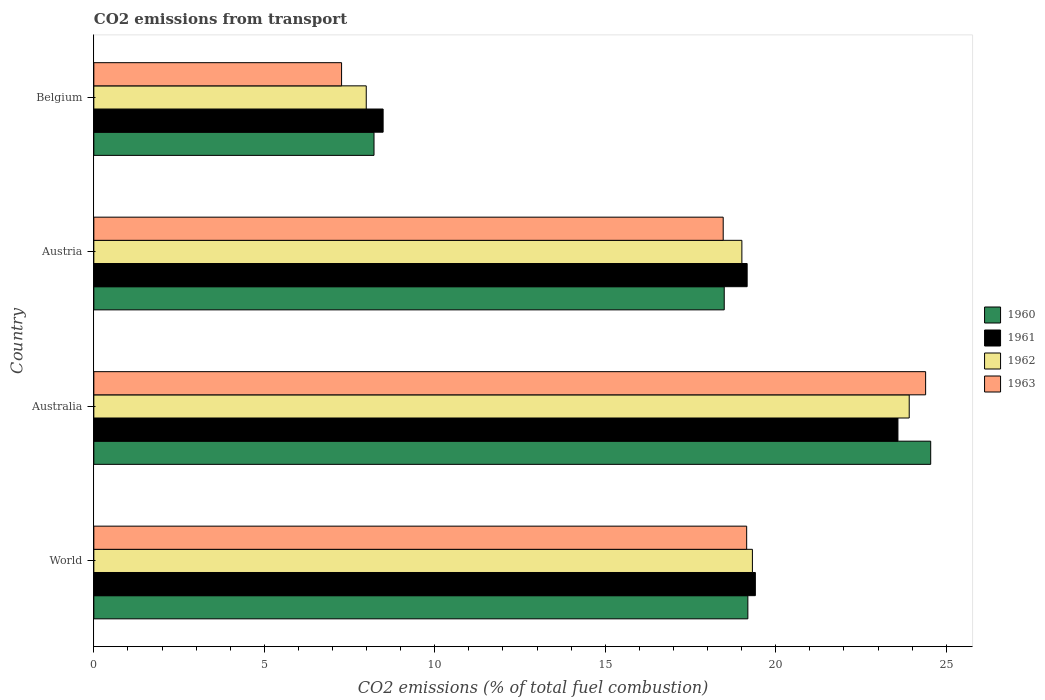How many different coloured bars are there?
Offer a terse response. 4. How many groups of bars are there?
Keep it short and to the point. 4. Are the number of bars on each tick of the Y-axis equal?
Your answer should be compact. Yes. How many bars are there on the 4th tick from the top?
Your response must be concise. 4. How many bars are there on the 2nd tick from the bottom?
Ensure brevity in your answer.  4. What is the label of the 1st group of bars from the top?
Your answer should be compact. Belgium. In how many cases, is the number of bars for a given country not equal to the number of legend labels?
Make the answer very short. 0. What is the total CO2 emitted in 1963 in World?
Keep it short and to the point. 19.15. Across all countries, what is the maximum total CO2 emitted in 1961?
Provide a succinct answer. 23.59. Across all countries, what is the minimum total CO2 emitted in 1961?
Your answer should be compact. 8.49. In which country was the total CO2 emitted in 1960 minimum?
Your answer should be compact. Belgium. What is the total total CO2 emitted in 1961 in the graph?
Your answer should be compact. 70.64. What is the difference between the total CO2 emitted in 1962 in Belgium and that in World?
Keep it short and to the point. -11.33. What is the difference between the total CO2 emitted in 1960 in Australia and the total CO2 emitted in 1963 in World?
Give a very brief answer. 5.4. What is the average total CO2 emitted in 1961 per country?
Give a very brief answer. 17.66. What is the difference between the total CO2 emitted in 1962 and total CO2 emitted in 1963 in Austria?
Provide a succinct answer. 0.55. In how many countries, is the total CO2 emitted in 1960 greater than 24 ?
Give a very brief answer. 1. What is the ratio of the total CO2 emitted in 1960 in Austria to that in Belgium?
Give a very brief answer. 2.25. What is the difference between the highest and the second highest total CO2 emitted in 1962?
Ensure brevity in your answer.  4.6. What is the difference between the highest and the lowest total CO2 emitted in 1962?
Ensure brevity in your answer.  15.93. In how many countries, is the total CO2 emitted in 1963 greater than the average total CO2 emitted in 1963 taken over all countries?
Provide a short and direct response. 3. Is the sum of the total CO2 emitted in 1961 in Belgium and World greater than the maximum total CO2 emitted in 1962 across all countries?
Your answer should be very brief. Yes. Is it the case that in every country, the sum of the total CO2 emitted in 1962 and total CO2 emitted in 1963 is greater than the total CO2 emitted in 1961?
Offer a terse response. Yes. How many countries are there in the graph?
Provide a short and direct response. 4. Does the graph contain any zero values?
Give a very brief answer. No. How are the legend labels stacked?
Offer a very short reply. Vertical. What is the title of the graph?
Ensure brevity in your answer.  CO2 emissions from transport. Does "2004" appear as one of the legend labels in the graph?
Your response must be concise. No. What is the label or title of the X-axis?
Ensure brevity in your answer.  CO2 emissions (% of total fuel combustion). What is the CO2 emissions (% of total fuel combustion) of 1960 in World?
Keep it short and to the point. 19.18. What is the CO2 emissions (% of total fuel combustion) in 1961 in World?
Make the answer very short. 19.4. What is the CO2 emissions (% of total fuel combustion) in 1962 in World?
Keep it short and to the point. 19.32. What is the CO2 emissions (% of total fuel combustion) in 1963 in World?
Provide a short and direct response. 19.15. What is the CO2 emissions (% of total fuel combustion) of 1960 in Australia?
Your answer should be compact. 24.55. What is the CO2 emissions (% of total fuel combustion) in 1961 in Australia?
Make the answer very short. 23.59. What is the CO2 emissions (% of total fuel combustion) of 1962 in Australia?
Your answer should be compact. 23.92. What is the CO2 emissions (% of total fuel combustion) in 1963 in Australia?
Your response must be concise. 24.4. What is the CO2 emissions (% of total fuel combustion) of 1960 in Austria?
Your answer should be very brief. 18.49. What is the CO2 emissions (% of total fuel combustion) in 1961 in Austria?
Offer a very short reply. 19.16. What is the CO2 emissions (% of total fuel combustion) in 1962 in Austria?
Provide a succinct answer. 19.01. What is the CO2 emissions (% of total fuel combustion) of 1963 in Austria?
Your answer should be compact. 18.46. What is the CO2 emissions (% of total fuel combustion) of 1960 in Belgium?
Offer a very short reply. 8.22. What is the CO2 emissions (% of total fuel combustion) of 1961 in Belgium?
Offer a very short reply. 8.49. What is the CO2 emissions (% of total fuel combustion) of 1962 in Belgium?
Your answer should be compact. 7.99. What is the CO2 emissions (% of total fuel combustion) of 1963 in Belgium?
Offer a terse response. 7.27. Across all countries, what is the maximum CO2 emissions (% of total fuel combustion) in 1960?
Offer a very short reply. 24.55. Across all countries, what is the maximum CO2 emissions (% of total fuel combustion) in 1961?
Make the answer very short. 23.59. Across all countries, what is the maximum CO2 emissions (% of total fuel combustion) of 1962?
Ensure brevity in your answer.  23.92. Across all countries, what is the maximum CO2 emissions (% of total fuel combustion) of 1963?
Offer a very short reply. 24.4. Across all countries, what is the minimum CO2 emissions (% of total fuel combustion) of 1960?
Provide a succinct answer. 8.22. Across all countries, what is the minimum CO2 emissions (% of total fuel combustion) of 1961?
Provide a short and direct response. 8.49. Across all countries, what is the minimum CO2 emissions (% of total fuel combustion) of 1962?
Provide a succinct answer. 7.99. Across all countries, what is the minimum CO2 emissions (% of total fuel combustion) in 1963?
Your answer should be compact. 7.27. What is the total CO2 emissions (% of total fuel combustion) of 1960 in the graph?
Give a very brief answer. 70.44. What is the total CO2 emissions (% of total fuel combustion) in 1961 in the graph?
Ensure brevity in your answer.  70.64. What is the total CO2 emissions (% of total fuel combustion) of 1962 in the graph?
Provide a succinct answer. 70.23. What is the total CO2 emissions (% of total fuel combustion) in 1963 in the graph?
Provide a short and direct response. 69.27. What is the difference between the CO2 emissions (% of total fuel combustion) of 1960 in World and that in Australia?
Your answer should be very brief. -5.36. What is the difference between the CO2 emissions (% of total fuel combustion) in 1961 in World and that in Australia?
Ensure brevity in your answer.  -4.18. What is the difference between the CO2 emissions (% of total fuel combustion) of 1962 in World and that in Australia?
Offer a terse response. -4.6. What is the difference between the CO2 emissions (% of total fuel combustion) of 1963 in World and that in Australia?
Provide a succinct answer. -5.25. What is the difference between the CO2 emissions (% of total fuel combustion) in 1960 in World and that in Austria?
Make the answer very short. 0.69. What is the difference between the CO2 emissions (% of total fuel combustion) of 1961 in World and that in Austria?
Provide a short and direct response. 0.24. What is the difference between the CO2 emissions (% of total fuel combustion) in 1962 in World and that in Austria?
Keep it short and to the point. 0.31. What is the difference between the CO2 emissions (% of total fuel combustion) in 1963 in World and that in Austria?
Keep it short and to the point. 0.69. What is the difference between the CO2 emissions (% of total fuel combustion) in 1960 in World and that in Belgium?
Your response must be concise. 10.96. What is the difference between the CO2 emissions (% of total fuel combustion) of 1961 in World and that in Belgium?
Give a very brief answer. 10.92. What is the difference between the CO2 emissions (% of total fuel combustion) of 1962 in World and that in Belgium?
Ensure brevity in your answer.  11.33. What is the difference between the CO2 emissions (% of total fuel combustion) of 1963 in World and that in Belgium?
Keep it short and to the point. 11.88. What is the difference between the CO2 emissions (% of total fuel combustion) of 1960 in Australia and that in Austria?
Make the answer very short. 6.06. What is the difference between the CO2 emissions (% of total fuel combustion) of 1961 in Australia and that in Austria?
Provide a succinct answer. 4.42. What is the difference between the CO2 emissions (% of total fuel combustion) of 1962 in Australia and that in Austria?
Offer a very short reply. 4.91. What is the difference between the CO2 emissions (% of total fuel combustion) of 1963 in Australia and that in Austria?
Your answer should be very brief. 5.94. What is the difference between the CO2 emissions (% of total fuel combustion) of 1960 in Australia and that in Belgium?
Make the answer very short. 16.33. What is the difference between the CO2 emissions (% of total fuel combustion) in 1961 in Australia and that in Belgium?
Offer a terse response. 15.1. What is the difference between the CO2 emissions (% of total fuel combustion) in 1962 in Australia and that in Belgium?
Give a very brief answer. 15.93. What is the difference between the CO2 emissions (% of total fuel combustion) of 1963 in Australia and that in Belgium?
Provide a short and direct response. 17.13. What is the difference between the CO2 emissions (% of total fuel combustion) of 1960 in Austria and that in Belgium?
Offer a very short reply. 10.27. What is the difference between the CO2 emissions (% of total fuel combustion) of 1961 in Austria and that in Belgium?
Your response must be concise. 10.68. What is the difference between the CO2 emissions (% of total fuel combustion) in 1962 in Austria and that in Belgium?
Your answer should be very brief. 11.02. What is the difference between the CO2 emissions (% of total fuel combustion) of 1963 in Austria and that in Belgium?
Provide a succinct answer. 11.19. What is the difference between the CO2 emissions (% of total fuel combustion) in 1960 in World and the CO2 emissions (% of total fuel combustion) in 1961 in Australia?
Your response must be concise. -4.4. What is the difference between the CO2 emissions (% of total fuel combustion) in 1960 in World and the CO2 emissions (% of total fuel combustion) in 1962 in Australia?
Keep it short and to the point. -4.73. What is the difference between the CO2 emissions (% of total fuel combustion) of 1960 in World and the CO2 emissions (% of total fuel combustion) of 1963 in Australia?
Give a very brief answer. -5.21. What is the difference between the CO2 emissions (% of total fuel combustion) of 1961 in World and the CO2 emissions (% of total fuel combustion) of 1962 in Australia?
Provide a short and direct response. -4.51. What is the difference between the CO2 emissions (% of total fuel combustion) of 1961 in World and the CO2 emissions (% of total fuel combustion) of 1963 in Australia?
Offer a very short reply. -4.99. What is the difference between the CO2 emissions (% of total fuel combustion) of 1962 in World and the CO2 emissions (% of total fuel combustion) of 1963 in Australia?
Make the answer very short. -5.08. What is the difference between the CO2 emissions (% of total fuel combustion) of 1960 in World and the CO2 emissions (% of total fuel combustion) of 1961 in Austria?
Your response must be concise. 0.02. What is the difference between the CO2 emissions (% of total fuel combustion) in 1960 in World and the CO2 emissions (% of total fuel combustion) in 1962 in Austria?
Make the answer very short. 0.18. What is the difference between the CO2 emissions (% of total fuel combustion) in 1960 in World and the CO2 emissions (% of total fuel combustion) in 1963 in Austria?
Give a very brief answer. 0.72. What is the difference between the CO2 emissions (% of total fuel combustion) of 1961 in World and the CO2 emissions (% of total fuel combustion) of 1962 in Austria?
Keep it short and to the point. 0.4. What is the difference between the CO2 emissions (% of total fuel combustion) in 1961 in World and the CO2 emissions (% of total fuel combustion) in 1963 in Austria?
Your answer should be very brief. 0.94. What is the difference between the CO2 emissions (% of total fuel combustion) in 1962 in World and the CO2 emissions (% of total fuel combustion) in 1963 in Austria?
Give a very brief answer. 0.86. What is the difference between the CO2 emissions (% of total fuel combustion) of 1960 in World and the CO2 emissions (% of total fuel combustion) of 1961 in Belgium?
Your response must be concise. 10.7. What is the difference between the CO2 emissions (% of total fuel combustion) of 1960 in World and the CO2 emissions (% of total fuel combustion) of 1962 in Belgium?
Your response must be concise. 11.19. What is the difference between the CO2 emissions (% of total fuel combustion) in 1960 in World and the CO2 emissions (% of total fuel combustion) in 1963 in Belgium?
Your answer should be very brief. 11.92. What is the difference between the CO2 emissions (% of total fuel combustion) of 1961 in World and the CO2 emissions (% of total fuel combustion) of 1962 in Belgium?
Keep it short and to the point. 11.41. What is the difference between the CO2 emissions (% of total fuel combustion) of 1961 in World and the CO2 emissions (% of total fuel combustion) of 1963 in Belgium?
Make the answer very short. 12.14. What is the difference between the CO2 emissions (% of total fuel combustion) of 1962 in World and the CO2 emissions (% of total fuel combustion) of 1963 in Belgium?
Your answer should be very brief. 12.05. What is the difference between the CO2 emissions (% of total fuel combustion) of 1960 in Australia and the CO2 emissions (% of total fuel combustion) of 1961 in Austria?
Your answer should be compact. 5.38. What is the difference between the CO2 emissions (% of total fuel combustion) of 1960 in Australia and the CO2 emissions (% of total fuel combustion) of 1962 in Austria?
Your answer should be compact. 5.54. What is the difference between the CO2 emissions (% of total fuel combustion) of 1960 in Australia and the CO2 emissions (% of total fuel combustion) of 1963 in Austria?
Offer a terse response. 6.09. What is the difference between the CO2 emissions (% of total fuel combustion) in 1961 in Australia and the CO2 emissions (% of total fuel combustion) in 1962 in Austria?
Provide a succinct answer. 4.58. What is the difference between the CO2 emissions (% of total fuel combustion) of 1961 in Australia and the CO2 emissions (% of total fuel combustion) of 1963 in Austria?
Keep it short and to the point. 5.13. What is the difference between the CO2 emissions (% of total fuel combustion) of 1962 in Australia and the CO2 emissions (% of total fuel combustion) of 1963 in Austria?
Ensure brevity in your answer.  5.46. What is the difference between the CO2 emissions (% of total fuel combustion) of 1960 in Australia and the CO2 emissions (% of total fuel combustion) of 1961 in Belgium?
Provide a short and direct response. 16.06. What is the difference between the CO2 emissions (% of total fuel combustion) in 1960 in Australia and the CO2 emissions (% of total fuel combustion) in 1962 in Belgium?
Offer a very short reply. 16.56. What is the difference between the CO2 emissions (% of total fuel combustion) in 1960 in Australia and the CO2 emissions (% of total fuel combustion) in 1963 in Belgium?
Provide a succinct answer. 17.28. What is the difference between the CO2 emissions (% of total fuel combustion) of 1961 in Australia and the CO2 emissions (% of total fuel combustion) of 1962 in Belgium?
Provide a short and direct response. 15.59. What is the difference between the CO2 emissions (% of total fuel combustion) in 1961 in Australia and the CO2 emissions (% of total fuel combustion) in 1963 in Belgium?
Ensure brevity in your answer.  16.32. What is the difference between the CO2 emissions (% of total fuel combustion) in 1962 in Australia and the CO2 emissions (% of total fuel combustion) in 1963 in Belgium?
Offer a very short reply. 16.65. What is the difference between the CO2 emissions (% of total fuel combustion) of 1960 in Austria and the CO2 emissions (% of total fuel combustion) of 1961 in Belgium?
Provide a succinct answer. 10. What is the difference between the CO2 emissions (% of total fuel combustion) in 1960 in Austria and the CO2 emissions (% of total fuel combustion) in 1962 in Belgium?
Your response must be concise. 10.5. What is the difference between the CO2 emissions (% of total fuel combustion) in 1960 in Austria and the CO2 emissions (% of total fuel combustion) in 1963 in Belgium?
Ensure brevity in your answer.  11.22. What is the difference between the CO2 emissions (% of total fuel combustion) in 1961 in Austria and the CO2 emissions (% of total fuel combustion) in 1962 in Belgium?
Your answer should be very brief. 11.17. What is the difference between the CO2 emissions (% of total fuel combustion) in 1961 in Austria and the CO2 emissions (% of total fuel combustion) in 1963 in Belgium?
Offer a very short reply. 11.9. What is the difference between the CO2 emissions (% of total fuel combustion) of 1962 in Austria and the CO2 emissions (% of total fuel combustion) of 1963 in Belgium?
Give a very brief answer. 11.74. What is the average CO2 emissions (% of total fuel combustion) of 1960 per country?
Your answer should be very brief. 17.61. What is the average CO2 emissions (% of total fuel combustion) in 1961 per country?
Your answer should be very brief. 17.66. What is the average CO2 emissions (% of total fuel combustion) of 1962 per country?
Keep it short and to the point. 17.56. What is the average CO2 emissions (% of total fuel combustion) in 1963 per country?
Your answer should be compact. 17.32. What is the difference between the CO2 emissions (% of total fuel combustion) of 1960 and CO2 emissions (% of total fuel combustion) of 1961 in World?
Provide a succinct answer. -0.22. What is the difference between the CO2 emissions (% of total fuel combustion) in 1960 and CO2 emissions (% of total fuel combustion) in 1962 in World?
Provide a short and direct response. -0.13. What is the difference between the CO2 emissions (% of total fuel combustion) of 1960 and CO2 emissions (% of total fuel combustion) of 1963 in World?
Ensure brevity in your answer.  0.03. What is the difference between the CO2 emissions (% of total fuel combustion) in 1961 and CO2 emissions (% of total fuel combustion) in 1962 in World?
Your response must be concise. 0.09. What is the difference between the CO2 emissions (% of total fuel combustion) in 1961 and CO2 emissions (% of total fuel combustion) in 1963 in World?
Your answer should be compact. 0.25. What is the difference between the CO2 emissions (% of total fuel combustion) in 1962 and CO2 emissions (% of total fuel combustion) in 1963 in World?
Ensure brevity in your answer.  0.17. What is the difference between the CO2 emissions (% of total fuel combustion) of 1960 and CO2 emissions (% of total fuel combustion) of 1961 in Australia?
Provide a short and direct response. 0.96. What is the difference between the CO2 emissions (% of total fuel combustion) in 1960 and CO2 emissions (% of total fuel combustion) in 1962 in Australia?
Offer a very short reply. 0.63. What is the difference between the CO2 emissions (% of total fuel combustion) of 1960 and CO2 emissions (% of total fuel combustion) of 1963 in Australia?
Keep it short and to the point. 0.15. What is the difference between the CO2 emissions (% of total fuel combustion) of 1961 and CO2 emissions (% of total fuel combustion) of 1962 in Australia?
Make the answer very short. -0.33. What is the difference between the CO2 emissions (% of total fuel combustion) in 1961 and CO2 emissions (% of total fuel combustion) in 1963 in Australia?
Your response must be concise. -0.81. What is the difference between the CO2 emissions (% of total fuel combustion) of 1962 and CO2 emissions (% of total fuel combustion) of 1963 in Australia?
Your response must be concise. -0.48. What is the difference between the CO2 emissions (% of total fuel combustion) of 1960 and CO2 emissions (% of total fuel combustion) of 1961 in Austria?
Your response must be concise. -0.67. What is the difference between the CO2 emissions (% of total fuel combustion) in 1960 and CO2 emissions (% of total fuel combustion) in 1962 in Austria?
Offer a terse response. -0.52. What is the difference between the CO2 emissions (% of total fuel combustion) of 1960 and CO2 emissions (% of total fuel combustion) of 1963 in Austria?
Offer a terse response. 0.03. What is the difference between the CO2 emissions (% of total fuel combustion) of 1961 and CO2 emissions (% of total fuel combustion) of 1962 in Austria?
Your answer should be very brief. 0.15. What is the difference between the CO2 emissions (% of total fuel combustion) of 1961 and CO2 emissions (% of total fuel combustion) of 1963 in Austria?
Make the answer very short. 0.7. What is the difference between the CO2 emissions (% of total fuel combustion) in 1962 and CO2 emissions (% of total fuel combustion) in 1963 in Austria?
Provide a short and direct response. 0.55. What is the difference between the CO2 emissions (% of total fuel combustion) in 1960 and CO2 emissions (% of total fuel combustion) in 1961 in Belgium?
Your answer should be very brief. -0.27. What is the difference between the CO2 emissions (% of total fuel combustion) of 1960 and CO2 emissions (% of total fuel combustion) of 1962 in Belgium?
Give a very brief answer. 0.23. What is the difference between the CO2 emissions (% of total fuel combustion) in 1960 and CO2 emissions (% of total fuel combustion) in 1963 in Belgium?
Your answer should be very brief. 0.95. What is the difference between the CO2 emissions (% of total fuel combustion) of 1961 and CO2 emissions (% of total fuel combustion) of 1962 in Belgium?
Your answer should be compact. 0.49. What is the difference between the CO2 emissions (% of total fuel combustion) of 1961 and CO2 emissions (% of total fuel combustion) of 1963 in Belgium?
Offer a very short reply. 1.22. What is the difference between the CO2 emissions (% of total fuel combustion) in 1962 and CO2 emissions (% of total fuel combustion) in 1963 in Belgium?
Offer a very short reply. 0.72. What is the ratio of the CO2 emissions (% of total fuel combustion) in 1960 in World to that in Australia?
Give a very brief answer. 0.78. What is the ratio of the CO2 emissions (% of total fuel combustion) of 1961 in World to that in Australia?
Offer a very short reply. 0.82. What is the ratio of the CO2 emissions (% of total fuel combustion) in 1962 in World to that in Australia?
Provide a short and direct response. 0.81. What is the ratio of the CO2 emissions (% of total fuel combustion) in 1963 in World to that in Australia?
Provide a succinct answer. 0.78. What is the ratio of the CO2 emissions (% of total fuel combustion) in 1960 in World to that in Austria?
Your answer should be very brief. 1.04. What is the ratio of the CO2 emissions (% of total fuel combustion) of 1961 in World to that in Austria?
Offer a terse response. 1.01. What is the ratio of the CO2 emissions (% of total fuel combustion) of 1962 in World to that in Austria?
Your answer should be compact. 1.02. What is the ratio of the CO2 emissions (% of total fuel combustion) in 1963 in World to that in Austria?
Make the answer very short. 1.04. What is the ratio of the CO2 emissions (% of total fuel combustion) in 1960 in World to that in Belgium?
Offer a very short reply. 2.33. What is the ratio of the CO2 emissions (% of total fuel combustion) in 1961 in World to that in Belgium?
Your response must be concise. 2.29. What is the ratio of the CO2 emissions (% of total fuel combustion) in 1962 in World to that in Belgium?
Give a very brief answer. 2.42. What is the ratio of the CO2 emissions (% of total fuel combustion) in 1963 in World to that in Belgium?
Make the answer very short. 2.64. What is the ratio of the CO2 emissions (% of total fuel combustion) in 1960 in Australia to that in Austria?
Offer a very short reply. 1.33. What is the ratio of the CO2 emissions (% of total fuel combustion) in 1961 in Australia to that in Austria?
Your answer should be very brief. 1.23. What is the ratio of the CO2 emissions (% of total fuel combustion) of 1962 in Australia to that in Austria?
Your answer should be very brief. 1.26. What is the ratio of the CO2 emissions (% of total fuel combustion) in 1963 in Australia to that in Austria?
Provide a succinct answer. 1.32. What is the ratio of the CO2 emissions (% of total fuel combustion) in 1960 in Australia to that in Belgium?
Your answer should be compact. 2.99. What is the ratio of the CO2 emissions (% of total fuel combustion) in 1961 in Australia to that in Belgium?
Give a very brief answer. 2.78. What is the ratio of the CO2 emissions (% of total fuel combustion) of 1962 in Australia to that in Belgium?
Give a very brief answer. 2.99. What is the ratio of the CO2 emissions (% of total fuel combustion) of 1963 in Australia to that in Belgium?
Your answer should be very brief. 3.36. What is the ratio of the CO2 emissions (% of total fuel combustion) of 1960 in Austria to that in Belgium?
Provide a short and direct response. 2.25. What is the ratio of the CO2 emissions (% of total fuel combustion) in 1961 in Austria to that in Belgium?
Your answer should be compact. 2.26. What is the ratio of the CO2 emissions (% of total fuel combustion) in 1962 in Austria to that in Belgium?
Offer a terse response. 2.38. What is the ratio of the CO2 emissions (% of total fuel combustion) in 1963 in Austria to that in Belgium?
Your response must be concise. 2.54. What is the difference between the highest and the second highest CO2 emissions (% of total fuel combustion) of 1960?
Provide a short and direct response. 5.36. What is the difference between the highest and the second highest CO2 emissions (% of total fuel combustion) of 1961?
Ensure brevity in your answer.  4.18. What is the difference between the highest and the second highest CO2 emissions (% of total fuel combustion) of 1962?
Offer a terse response. 4.6. What is the difference between the highest and the second highest CO2 emissions (% of total fuel combustion) of 1963?
Your answer should be very brief. 5.25. What is the difference between the highest and the lowest CO2 emissions (% of total fuel combustion) in 1960?
Your answer should be compact. 16.33. What is the difference between the highest and the lowest CO2 emissions (% of total fuel combustion) of 1961?
Make the answer very short. 15.1. What is the difference between the highest and the lowest CO2 emissions (% of total fuel combustion) of 1962?
Your response must be concise. 15.93. What is the difference between the highest and the lowest CO2 emissions (% of total fuel combustion) in 1963?
Ensure brevity in your answer.  17.13. 